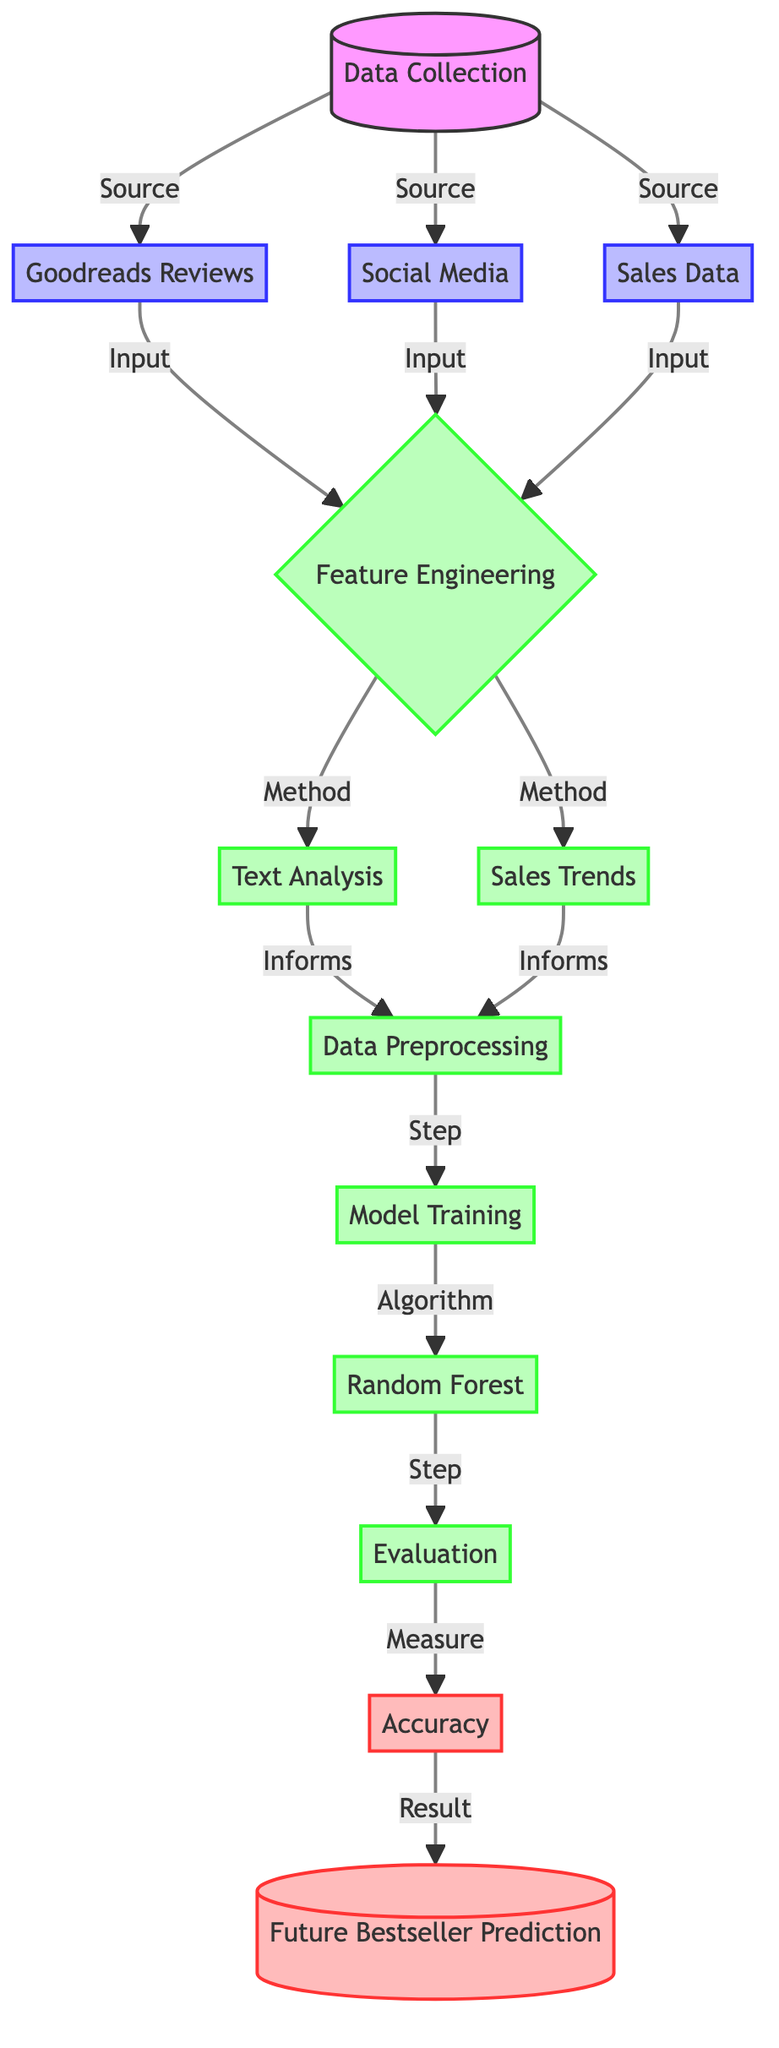What are the three sources for data collection? The diagram lists three sources for data collection, which are "Goodreads Reviews," "Social Media," and "Sales Data." These are shown as input nodes connected to the data collection node.
Answer: Goodreads Reviews, Social Media, Sales Data What process follows data collection? According to the flow of the diagram, after the data collection step, the next process is "Feature Engineering," which informs other processes.
Answer: Feature Engineering How many processes are involved in the diagram? By counting the nodes labeled as processes, there are six processes involved: Feature Engineering, Text Analysis, Sales Trends, Data Preprocessing, Model Training, and Evaluation.
Answer: Six What type of algorithm is used for model training? The diagram states that "Random Forest" is the specific algorithm used during the model training phase, indicating the approach utilized for predicting future bestsellers.
Answer: Random Forest What measurement is taken after model training? After the model training step, the diagram indicates that "Accuracy" is measured to evaluate the effectiveness of the model, which follows the evaluation process.
Answer: Accuracy Which process informs data preprocessing? From the diagram, both "Text Analysis" and "Sales Trends" inform the "Data Preprocessing" step, showing the culmination of various features into a structured format.
Answer: Text Analysis and Sales Trends What is the final output of the diagram? The end node of the diagram indicates that the final output is "Future Bestseller Prediction," which signifies the main goal of the machine learning model in the context of book trends.
Answer: Future Bestseller Prediction How is the relationship between sales data and feature engineering represented? The diagram illustrates that "Sales Data" is an input contributing to "Feature Engineering," signifying that sales metrics are utilized to derive features for the model.
Answer: Input relationship 